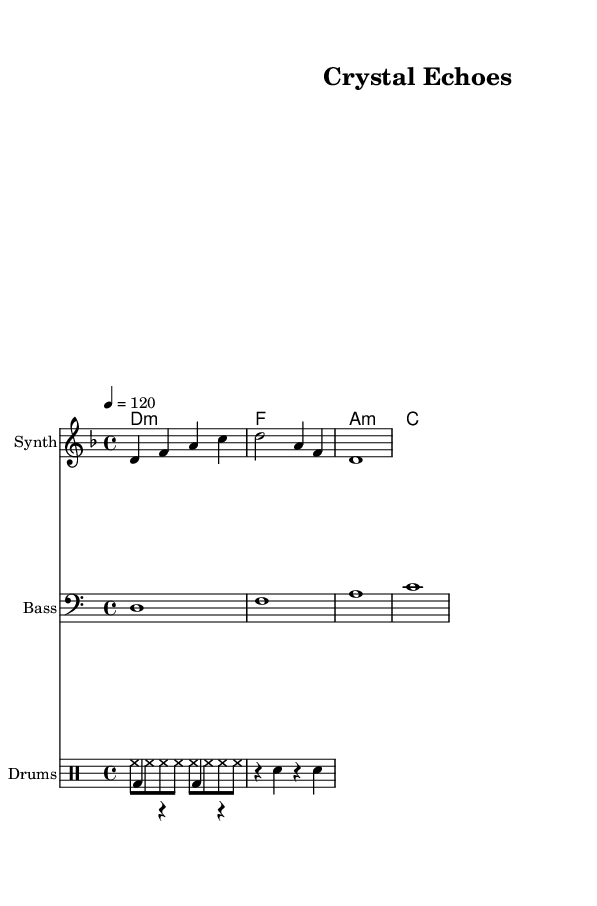What is the key signature of this music? The key signature is D minor, which has one flat (B flat). This can be determined by looking at the key signature symbol at the beginning of the staff.
Answer: D minor What is the time signature of this piece? The time signature is 4/4, indicated at the beginning of the score. This means there are four beats in each measure and the quarter note gets one beat.
Answer: 4/4 What is the tempo of this music? The tempo is indicated as 120 beats per minute, as shown in the tempo marking of the score. This specifies how fast the music should be played.
Answer: 120 How many measures are there in the melody? There are three measures in the melody, which can be counted from the melody staff where each measure is separated by vertical bar lines.
Answer: 3 What type of drum pattern is used in this piece? The drum pattern consists of a combination of hi-hat and bass drum in an upbeat pattern, followed by a combination of bass drum and snare drum in a downbeat pattern. This can be inferred from the drum notation in the drum staff.
Answer: Combination How is the harmony structured in this piece? The harmony follows a simple pattern, moving through the chords D minor, F major, A minor, and C major, which can be seen in the chord names written above the staff. This creates a typical ambient dance sound.
Answer: D minor, F, A minor, C What is the sound source of this ambient dance track? The sound source incorporates field recordings from mining sites and crystal caves, as described in the context of the piece rather than the sheet music itself. This provides a unique texture to the track.
Answer: Field recordings 